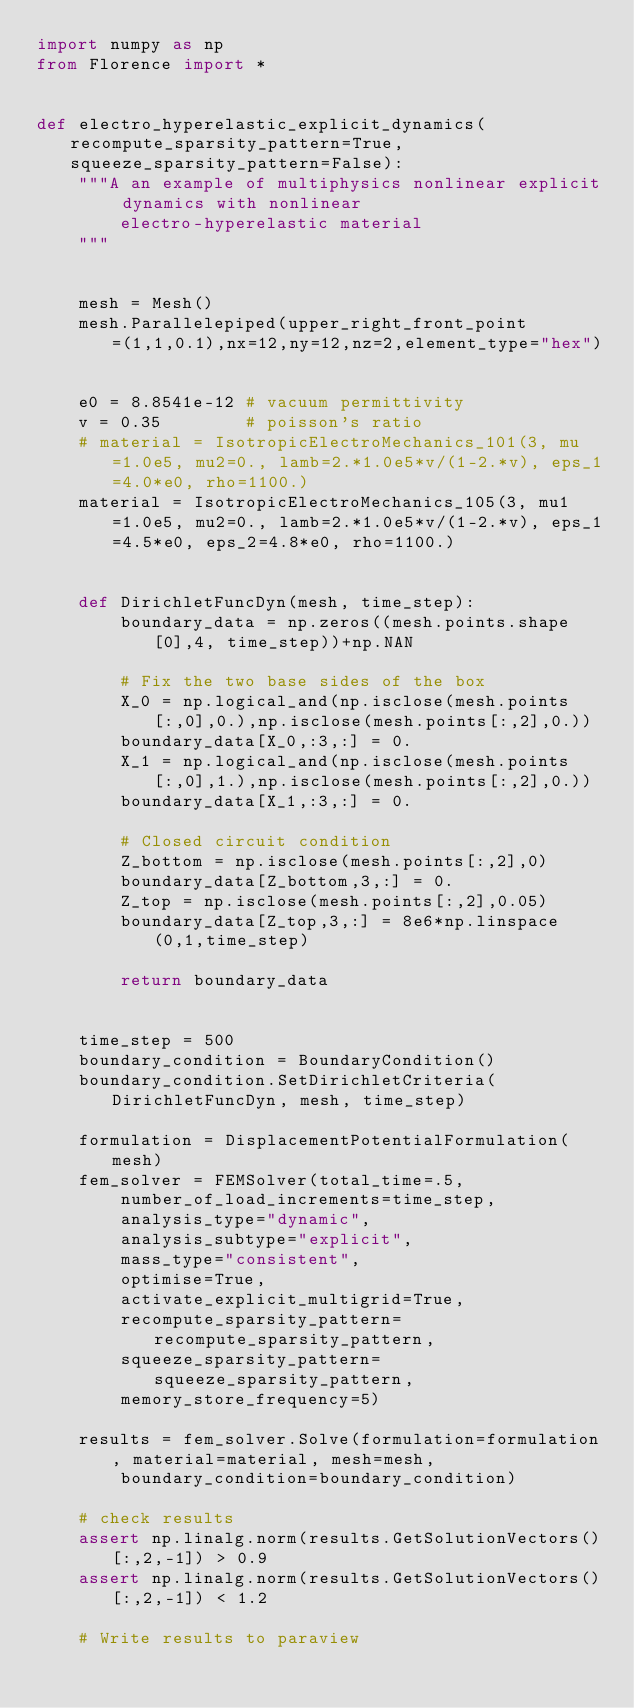Convert code to text. <code><loc_0><loc_0><loc_500><loc_500><_Python_>import numpy as np
from Florence import *


def electro_hyperelastic_explicit_dynamics(recompute_sparsity_pattern=True, squeeze_sparsity_pattern=False):
    """A an example of multiphysics nonlinear explicit dynamics with nonlinear
        electro-hyperelastic material
    """


    mesh = Mesh()
    mesh.Parallelepiped(upper_right_front_point=(1,1,0.1),nx=12,ny=12,nz=2,element_type="hex")


    e0 = 8.8541e-12 # vacuum permittivity
    v = 0.35        # poisson's ratio
    # material = IsotropicElectroMechanics_101(3, mu=1.0e5, mu2=0., lamb=2.*1.0e5*v/(1-2.*v), eps_1=4.0*e0, rho=1100.)
    material = IsotropicElectroMechanics_105(3, mu1=1.0e5, mu2=0., lamb=2.*1.0e5*v/(1-2.*v), eps_1=4.5*e0, eps_2=4.8*e0, rho=1100.)


    def DirichletFuncDyn(mesh, time_step):
        boundary_data = np.zeros((mesh.points.shape[0],4, time_step))+np.NAN

        # Fix the two base sides of the box
        X_0 = np.logical_and(np.isclose(mesh.points[:,0],0.),np.isclose(mesh.points[:,2],0.))
        boundary_data[X_0,:3,:] = 0.
        X_1 = np.logical_and(np.isclose(mesh.points[:,0],1.),np.isclose(mesh.points[:,2],0.))
        boundary_data[X_1,:3,:] = 0.

        # Closed circuit condition
        Z_bottom = np.isclose(mesh.points[:,2],0)
        boundary_data[Z_bottom,3,:] = 0.
        Z_top = np.isclose(mesh.points[:,2],0.05)
        boundary_data[Z_top,3,:] = 8e6*np.linspace(0,1,time_step)

        return boundary_data


    time_step = 500
    boundary_condition = BoundaryCondition()
    boundary_condition.SetDirichletCriteria(DirichletFuncDyn, mesh, time_step)

    formulation = DisplacementPotentialFormulation(mesh)
    fem_solver = FEMSolver(total_time=.5,
        number_of_load_increments=time_step,
        analysis_type="dynamic",
        analysis_subtype="explicit",
        mass_type="consistent",
        optimise=True,
        activate_explicit_multigrid=True,
        recompute_sparsity_pattern=recompute_sparsity_pattern,
        squeeze_sparsity_pattern=squeeze_sparsity_pattern,
        memory_store_frequency=5)

    results = fem_solver.Solve(formulation=formulation, material=material, mesh=mesh,
        boundary_condition=boundary_condition)

    # check results
    assert np.linalg.norm(results.GetSolutionVectors()[:,2,-1]) > 0.9
    assert np.linalg.norm(results.GetSolutionVectors()[:,2,-1]) < 1.2

    # Write results to paraview</code> 